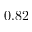<formula> <loc_0><loc_0><loc_500><loc_500>0 . 8 2</formula> 